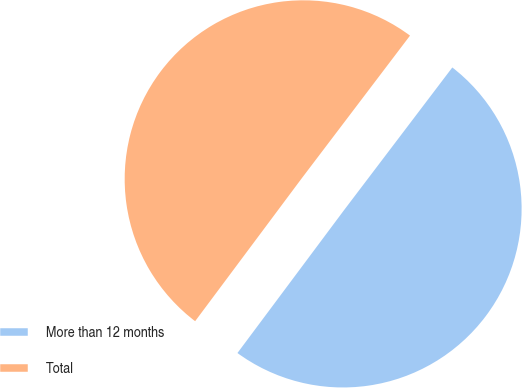<chart> <loc_0><loc_0><loc_500><loc_500><pie_chart><fcel>More than 12 months<fcel>Total<nl><fcel>49.87%<fcel>50.13%<nl></chart> 